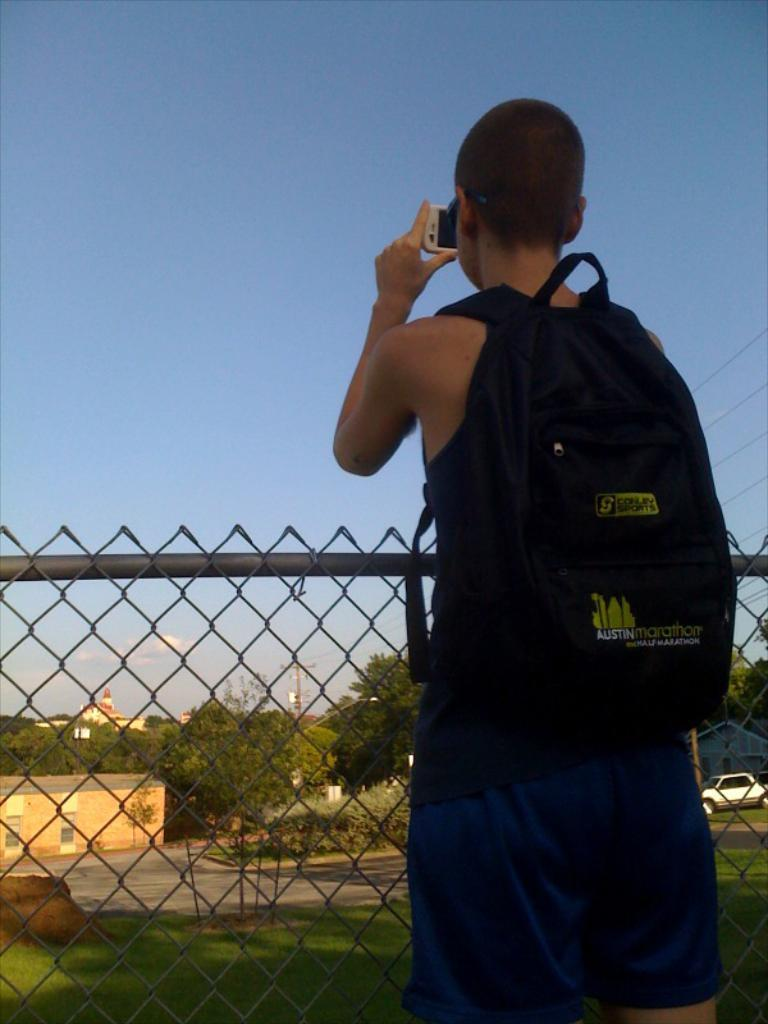What is the person in the image doing? The person is standing in the image. What is the person carrying in the image? The person is carrying a bag. What can be seen in the background of the image? There are trees and buildings in the background of the image. How many buildings are visible in the image? At least one building is visible in the image. What type of shirt is the person wearing in the image? The provided facts do not mention the type of shirt the person is wearing, so it cannot be determined from the image. 